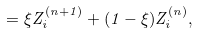Convert formula to latex. <formula><loc_0><loc_0><loc_500><loc_500>= \xi Z _ { i } ^ { ( n + 1 ) } + ( 1 - \xi ) Z _ { i } ^ { ( n ) } ,</formula> 